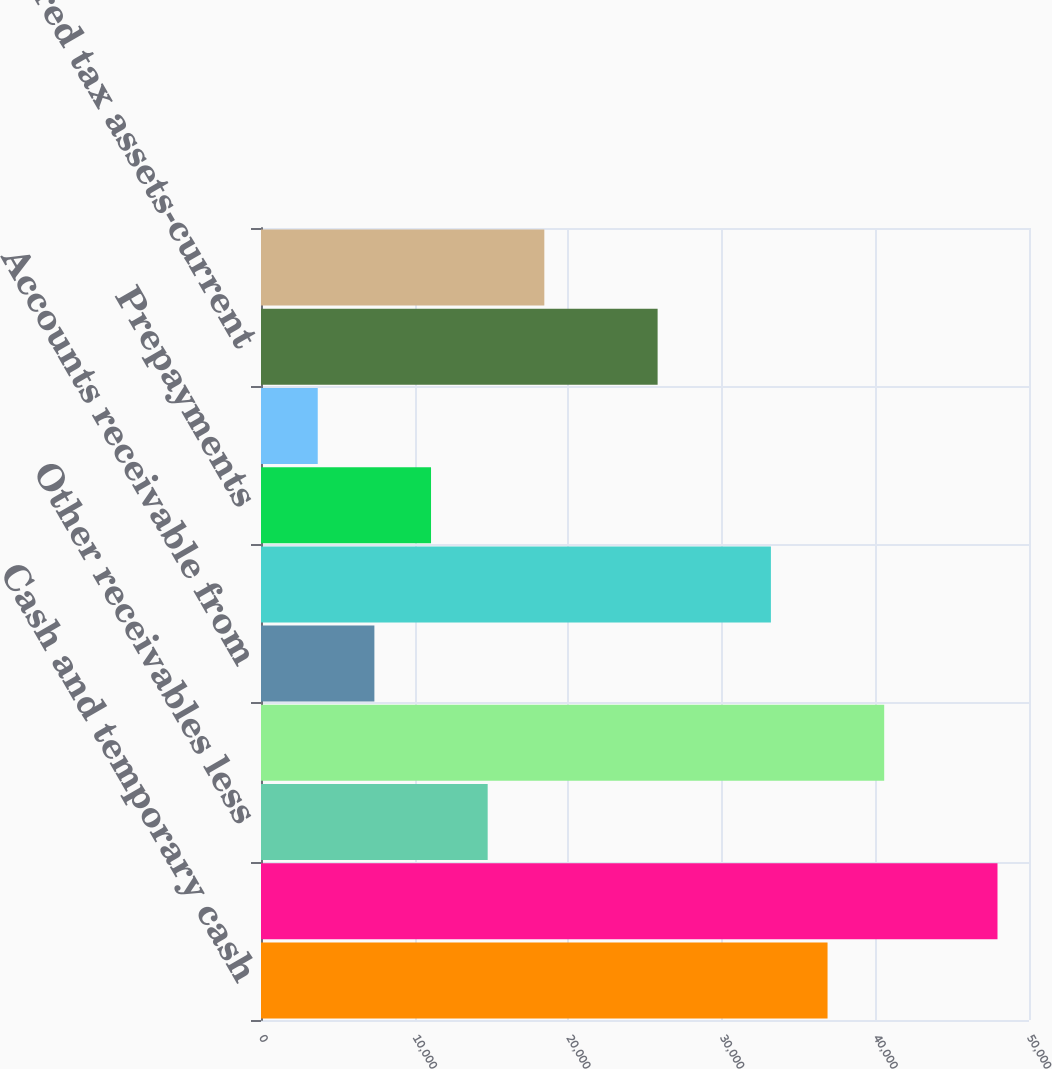<chart> <loc_0><loc_0><loc_500><loc_500><bar_chart><fcel>Cash and temporary cash<fcel>Accounts receivable -<fcel>Other receivables less<fcel>Accrued unbilled revenue<fcel>Accounts receivable from<fcel>Fuel oil gas in storage<fcel>Prepayments<fcel>Regulatory assets<fcel>Deferred tax assets-current<fcel>Other current assets<nl><fcel>36885<fcel>47948.7<fcel>14757.6<fcel>40572.9<fcel>7381.8<fcel>33197.1<fcel>11069.7<fcel>3693.9<fcel>25821.3<fcel>18445.5<nl></chart> 